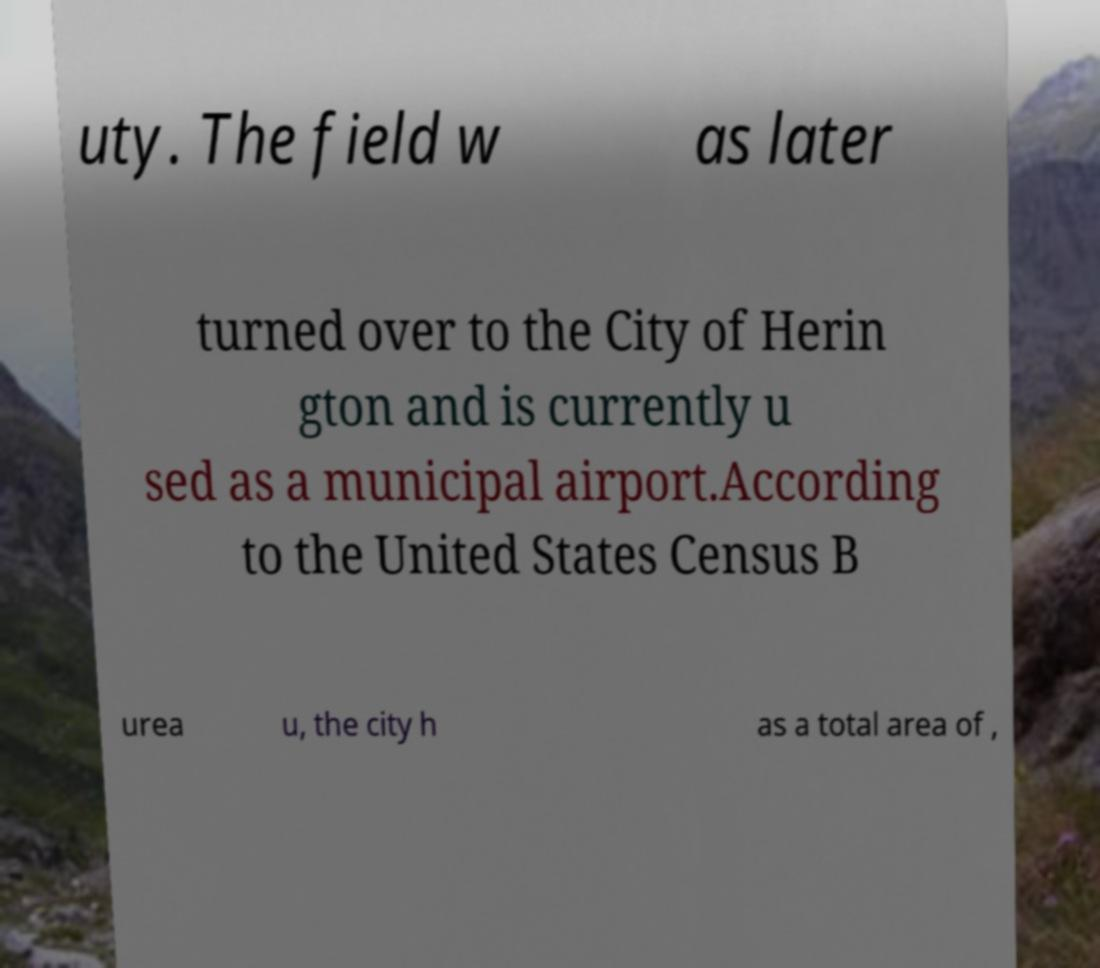Could you assist in decoding the text presented in this image and type it out clearly? uty. The field w as later turned over to the City of Herin gton and is currently u sed as a municipal airport.According to the United States Census B urea u, the city h as a total area of , 